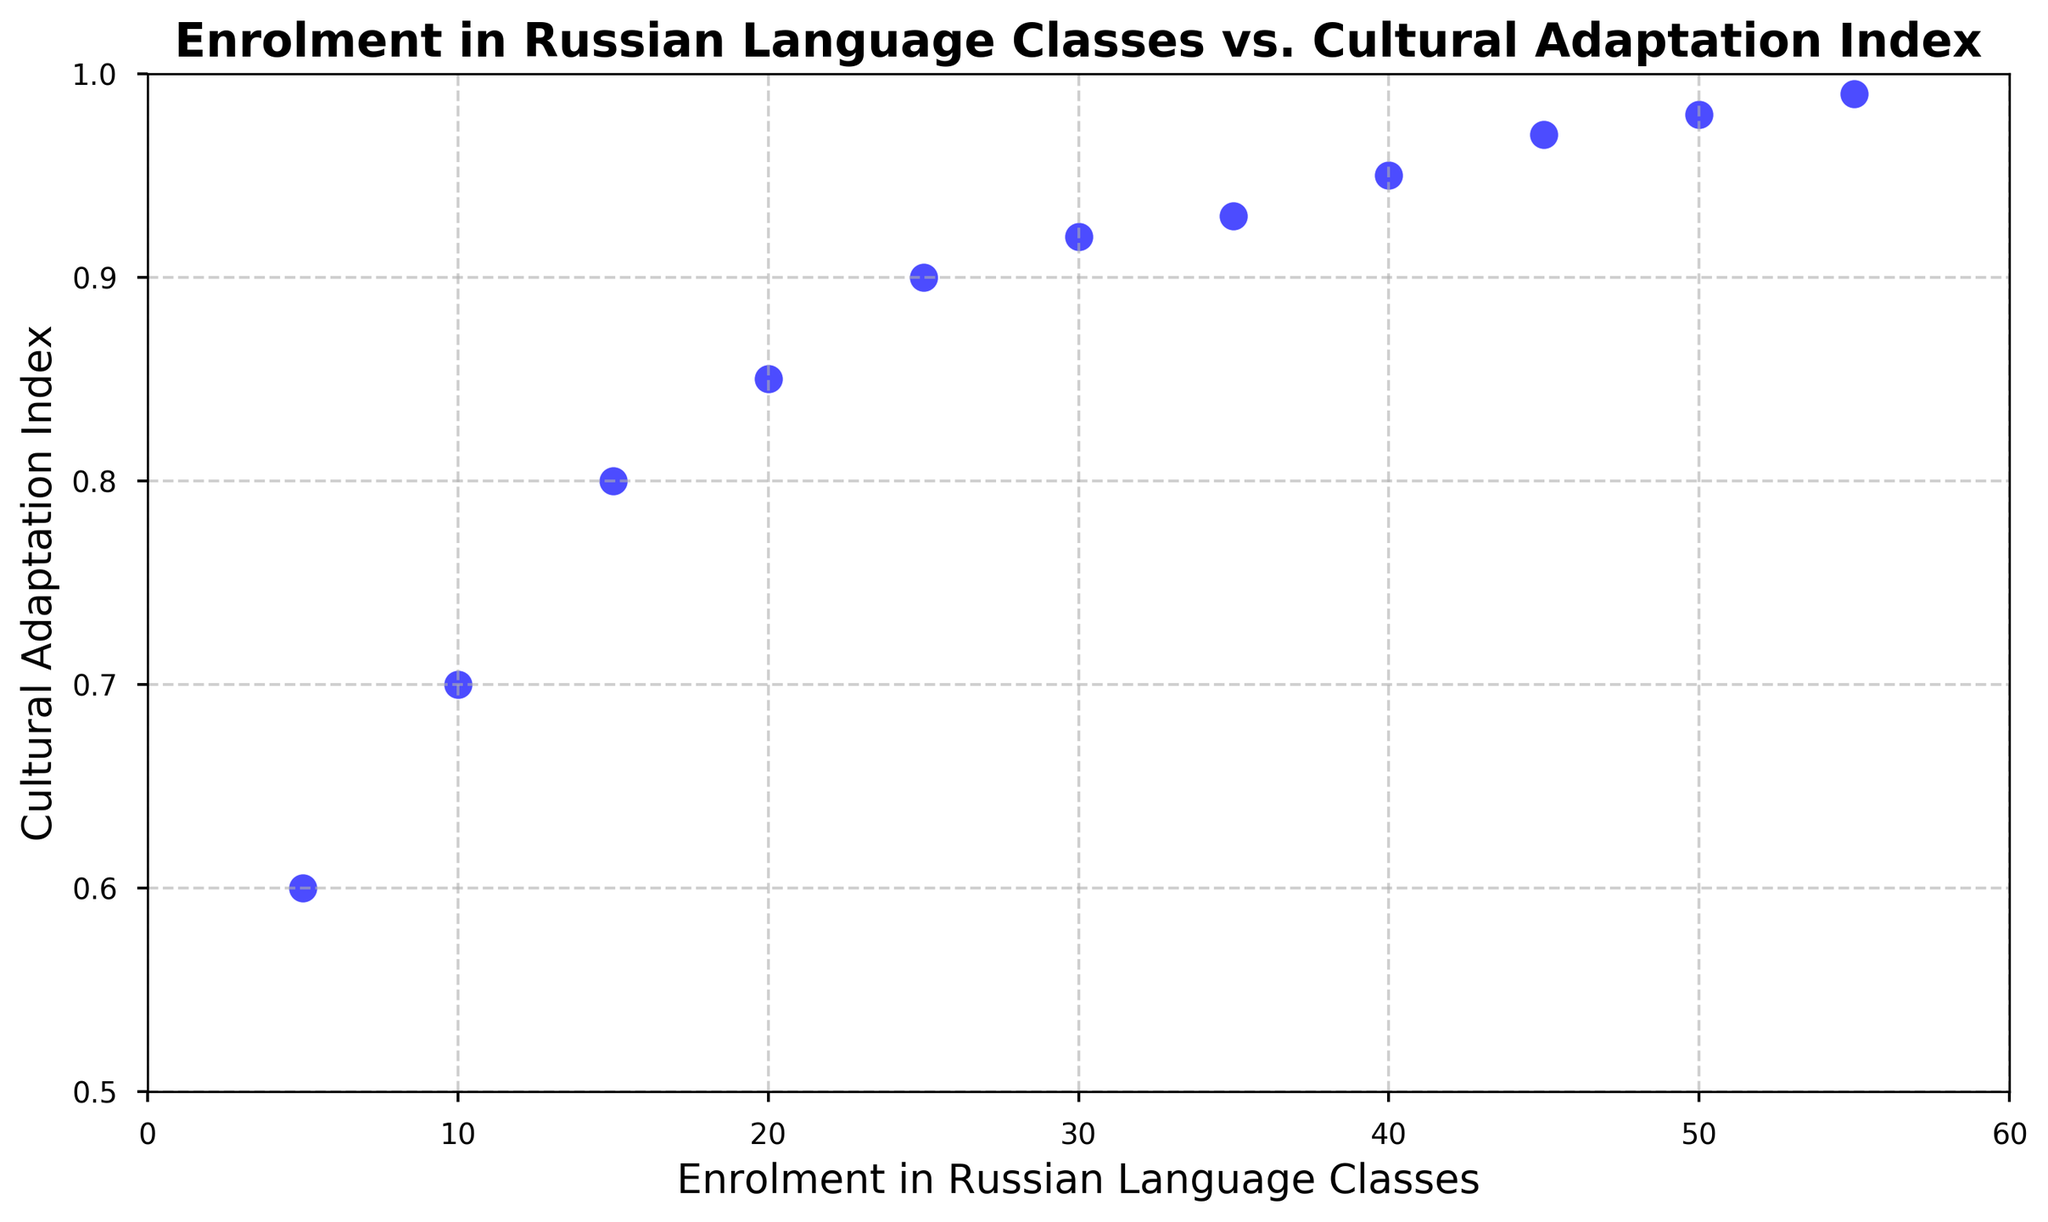What's the enrolment in Russian Language Classes when the Cultural Adaptation Index is 0.85? To determine this, locate the point on the scatter plot where the Cultural Adaptation Index is 0.85 on the y-axis. Follow the point horizontally to the x-axis to find the enrolment value.
Answer: 20 How many students have a Cultural Adaptation Index higher than 0.95? Identify and count the points on the scatter plot where the y-value (Cultural Adaptation Index) is greater than 0.95. The points correspond to the Cultural Adaptation Index of 0.97, 0.98, and 0.99.
Answer: 3 Do more points appear above or below the Cultural Adaptation Index of 0.9? Count the points above and below the y-value of 0.9. There are 6 points below and 5 points above 0.9.
Answer: Below What is the average Cultural Adaptation Index for enrolments of 40, 45, and 50? First, find the Cultural Adaptation Index for enrolments of 40, 45, and 50, which are 0.95, 0.97, and 0.98 respectively. Then, calculate the average: (0.95 + 0.97 + 0.98) / 3 = 2.90 / 3.
Answer: 0.97 Does the scatter plot exhibit a positive or negative trend between enrolment and the Cultural Adaptation Index? By observing the overall pattern of the points on the scatter plot, there is a clear upward trend; as enrolment increases, the Cultural Adaptation Index also increases.
Answer: Positive What is the highest Cultural Adaptation Index observed and what's the corresponding enrolment? Look for the point with the maximum y-value on the scatter plot. The highest Cultural Adaptation Index is 0.99, which corresponds to an enrolment of 55.
Answer: 0.99 and 55 Is there any enrolment where the Cultural Adaptation Index is below 0.7? Find any points on the scatter plot where the y-value (Cultural Adaptation Index) is below 0.7. Only the points corresponding to 5 and 10 enrollments fulfill this condition, with indices of 0.6 and 0.7 respectively.
Answer: Yes, 5 and 10 How much difference is there in the Cultural Adaptation Index between 15 and 25 enrolments? Find the Cultural Adaptation Index for 15 enrolments (0.8) and 25 enrolments (0.9). Subtract these values to find the difference: 0.9 - 0.8 = 0.1.
Answer: 0.1 